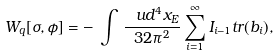<formula> <loc_0><loc_0><loc_500><loc_500>W _ { q } [ \sigma , \phi ] = - \, \int \, \frac { \ u d ^ { 4 } x _ { E } } { 3 2 \pi ^ { 2 } } \sum _ { i = 1 } ^ { \infty } I _ { i - 1 } t r ( b _ { i } ) ,</formula> 